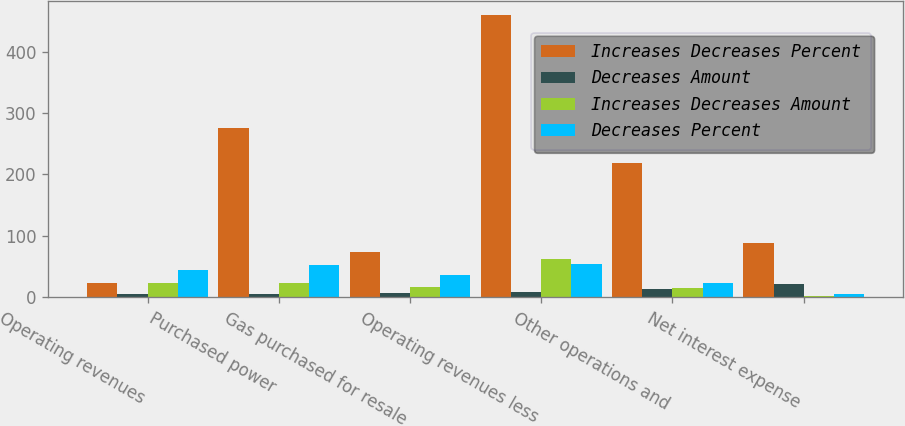Convert chart. <chart><loc_0><loc_0><loc_500><loc_500><stacked_bar_chart><ecel><fcel>Operating revenues<fcel>Purchased power<fcel>Gas purchased for resale<fcel>Operating revenues less<fcel>Other operations and<fcel>Net interest expense<nl><fcel>Increases Decreases Percent<fcel>23.8<fcel>276<fcel>73<fcel>459<fcel>218<fcel>88<nl><fcel>Decreases Amount<fcel>5.5<fcel>5.9<fcel>6.3<fcel>9.4<fcel>13.1<fcel>20.9<nl><fcel>Increases Decreases Amount<fcel>23.8<fcel>23.8<fcel>17<fcel>63<fcel>15<fcel>2<nl><fcel>Decreases Percent<fcel>43.7<fcel>52.9<fcel>36.2<fcel>53.8<fcel>23.8<fcel>5.9<nl></chart> 